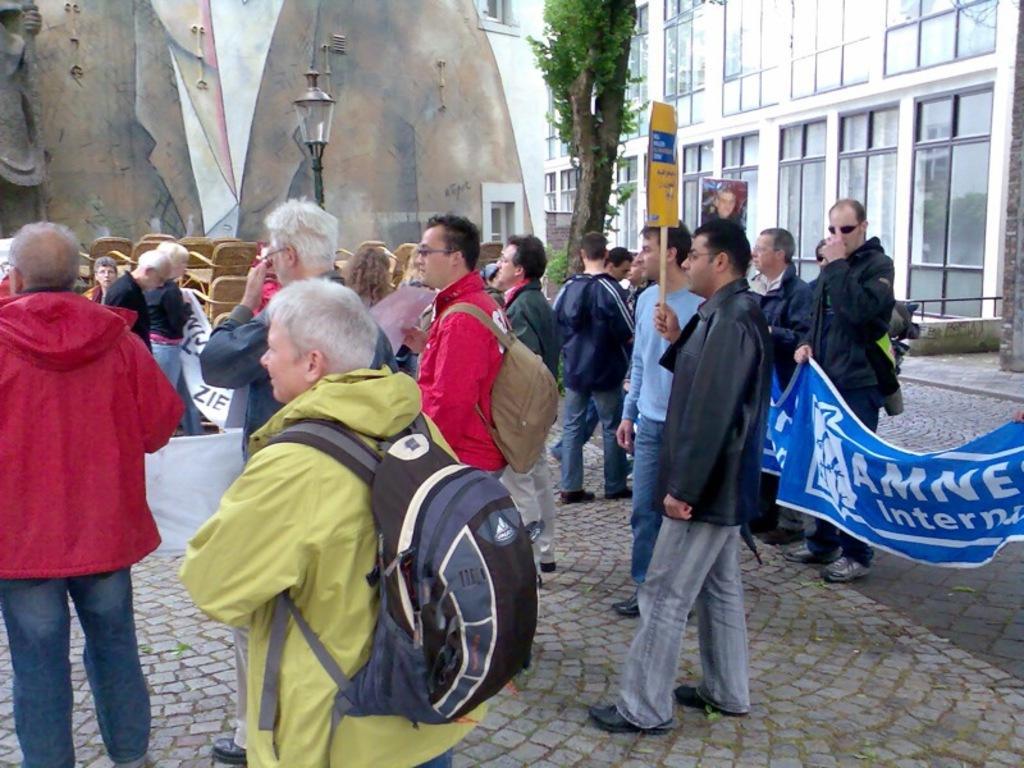Could you give a brief overview of what you see in this image? In this image I can see the ground, few persons standing and I can see few of them are holding boards and banners. I can see a tree, few buildings, a light pole, few windows of the building and I can see a statue to the left side of the image. 